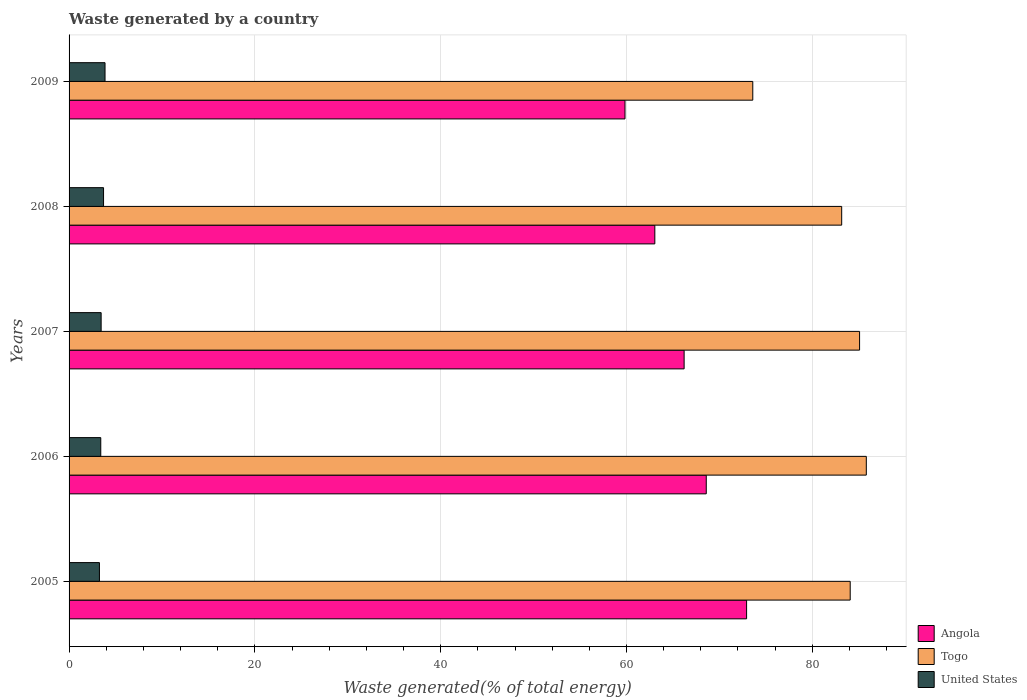How many groups of bars are there?
Make the answer very short. 5. How many bars are there on the 1st tick from the top?
Your answer should be very brief. 3. How many bars are there on the 4th tick from the bottom?
Ensure brevity in your answer.  3. What is the total waste generated in Angola in 2008?
Your answer should be very brief. 63.05. Across all years, what is the maximum total waste generated in Angola?
Provide a succinct answer. 72.93. Across all years, what is the minimum total waste generated in Angola?
Your answer should be compact. 59.84. What is the total total waste generated in Angola in the graph?
Make the answer very short. 330.61. What is the difference between the total waste generated in Angola in 2005 and that in 2008?
Your answer should be compact. 9.88. What is the difference between the total waste generated in United States in 2005 and the total waste generated in Angola in 2007?
Give a very brief answer. -62.94. What is the average total waste generated in Togo per year?
Provide a succinct answer. 82.35. In the year 2005, what is the difference between the total waste generated in Angola and total waste generated in Togo?
Provide a succinct answer. -11.15. What is the ratio of the total waste generated in United States in 2005 to that in 2008?
Ensure brevity in your answer.  0.88. What is the difference between the highest and the second highest total waste generated in Angola?
Offer a terse response. 4.34. What is the difference between the highest and the lowest total waste generated in Angola?
Your answer should be compact. 13.09. In how many years, is the total waste generated in Angola greater than the average total waste generated in Angola taken over all years?
Ensure brevity in your answer.  3. What does the 2nd bar from the bottom in 2006 represents?
Offer a very short reply. Togo. Is it the case that in every year, the sum of the total waste generated in United States and total waste generated in Angola is greater than the total waste generated in Togo?
Provide a short and direct response. No. How many years are there in the graph?
Give a very brief answer. 5. What is the difference between two consecutive major ticks on the X-axis?
Keep it short and to the point. 20. Are the values on the major ticks of X-axis written in scientific E-notation?
Keep it short and to the point. No. Does the graph contain any zero values?
Give a very brief answer. No. How are the legend labels stacked?
Keep it short and to the point. Vertical. What is the title of the graph?
Provide a succinct answer. Waste generated by a country. Does "Italy" appear as one of the legend labels in the graph?
Make the answer very short. No. What is the label or title of the X-axis?
Provide a succinct answer. Waste generated(% of total energy). What is the label or title of the Y-axis?
Offer a terse response. Years. What is the Waste generated(% of total energy) in Angola in 2005?
Keep it short and to the point. 72.93. What is the Waste generated(% of total energy) of Togo in 2005?
Your answer should be compact. 84.08. What is the Waste generated(% of total energy) in United States in 2005?
Your response must be concise. 3.27. What is the Waste generated(% of total energy) of Angola in 2006?
Provide a succinct answer. 68.59. What is the Waste generated(% of total energy) in Togo in 2006?
Your answer should be very brief. 85.82. What is the Waste generated(% of total energy) of United States in 2006?
Your response must be concise. 3.41. What is the Waste generated(% of total energy) of Angola in 2007?
Make the answer very short. 66.2. What is the Waste generated(% of total energy) in Togo in 2007?
Offer a terse response. 85.09. What is the Waste generated(% of total energy) of United States in 2007?
Your answer should be very brief. 3.45. What is the Waste generated(% of total energy) in Angola in 2008?
Your answer should be very brief. 63.05. What is the Waste generated(% of total energy) in Togo in 2008?
Give a very brief answer. 83.16. What is the Waste generated(% of total energy) of United States in 2008?
Your response must be concise. 3.71. What is the Waste generated(% of total energy) in Angola in 2009?
Provide a short and direct response. 59.84. What is the Waste generated(% of total energy) in Togo in 2009?
Ensure brevity in your answer.  73.59. What is the Waste generated(% of total energy) in United States in 2009?
Ensure brevity in your answer.  3.87. Across all years, what is the maximum Waste generated(% of total energy) of Angola?
Your response must be concise. 72.93. Across all years, what is the maximum Waste generated(% of total energy) of Togo?
Give a very brief answer. 85.82. Across all years, what is the maximum Waste generated(% of total energy) in United States?
Your answer should be compact. 3.87. Across all years, what is the minimum Waste generated(% of total energy) of Angola?
Offer a terse response. 59.84. Across all years, what is the minimum Waste generated(% of total energy) in Togo?
Offer a terse response. 73.59. Across all years, what is the minimum Waste generated(% of total energy) in United States?
Offer a terse response. 3.27. What is the total Waste generated(% of total energy) of Angola in the graph?
Give a very brief answer. 330.61. What is the total Waste generated(% of total energy) of Togo in the graph?
Offer a very short reply. 411.74. What is the total Waste generated(% of total energy) in United States in the graph?
Your answer should be compact. 17.71. What is the difference between the Waste generated(% of total energy) in Angola in 2005 and that in 2006?
Offer a very short reply. 4.34. What is the difference between the Waste generated(% of total energy) of Togo in 2005 and that in 2006?
Give a very brief answer. -1.73. What is the difference between the Waste generated(% of total energy) in United States in 2005 and that in 2006?
Your answer should be compact. -0.14. What is the difference between the Waste generated(% of total energy) of Angola in 2005 and that in 2007?
Make the answer very short. 6.72. What is the difference between the Waste generated(% of total energy) in Togo in 2005 and that in 2007?
Your answer should be compact. -1.01. What is the difference between the Waste generated(% of total energy) of United States in 2005 and that in 2007?
Give a very brief answer. -0.18. What is the difference between the Waste generated(% of total energy) in Angola in 2005 and that in 2008?
Provide a short and direct response. 9.88. What is the difference between the Waste generated(% of total energy) in Togo in 2005 and that in 2008?
Keep it short and to the point. 0.92. What is the difference between the Waste generated(% of total energy) of United States in 2005 and that in 2008?
Ensure brevity in your answer.  -0.44. What is the difference between the Waste generated(% of total energy) of Angola in 2005 and that in 2009?
Offer a terse response. 13.09. What is the difference between the Waste generated(% of total energy) of Togo in 2005 and that in 2009?
Your answer should be very brief. 10.49. What is the difference between the Waste generated(% of total energy) in United States in 2005 and that in 2009?
Provide a succinct answer. -0.6. What is the difference between the Waste generated(% of total energy) of Angola in 2006 and that in 2007?
Offer a terse response. 2.38. What is the difference between the Waste generated(% of total energy) of Togo in 2006 and that in 2007?
Provide a succinct answer. 0.73. What is the difference between the Waste generated(% of total energy) of United States in 2006 and that in 2007?
Provide a succinct answer. -0.04. What is the difference between the Waste generated(% of total energy) of Angola in 2006 and that in 2008?
Your answer should be very brief. 5.54. What is the difference between the Waste generated(% of total energy) in Togo in 2006 and that in 2008?
Give a very brief answer. 2.65. What is the difference between the Waste generated(% of total energy) of United States in 2006 and that in 2008?
Provide a short and direct response. -0.3. What is the difference between the Waste generated(% of total energy) in Angola in 2006 and that in 2009?
Offer a terse response. 8.75. What is the difference between the Waste generated(% of total energy) of Togo in 2006 and that in 2009?
Your answer should be compact. 12.22. What is the difference between the Waste generated(% of total energy) of United States in 2006 and that in 2009?
Make the answer very short. -0.46. What is the difference between the Waste generated(% of total energy) of Angola in 2007 and that in 2008?
Offer a very short reply. 3.15. What is the difference between the Waste generated(% of total energy) of Togo in 2007 and that in 2008?
Keep it short and to the point. 1.93. What is the difference between the Waste generated(% of total energy) in United States in 2007 and that in 2008?
Offer a terse response. -0.26. What is the difference between the Waste generated(% of total energy) of Angola in 2007 and that in 2009?
Offer a very short reply. 6.37. What is the difference between the Waste generated(% of total energy) of Togo in 2007 and that in 2009?
Your answer should be compact. 11.5. What is the difference between the Waste generated(% of total energy) in United States in 2007 and that in 2009?
Offer a very short reply. -0.42. What is the difference between the Waste generated(% of total energy) of Angola in 2008 and that in 2009?
Give a very brief answer. 3.21. What is the difference between the Waste generated(% of total energy) in Togo in 2008 and that in 2009?
Ensure brevity in your answer.  9.57. What is the difference between the Waste generated(% of total energy) in United States in 2008 and that in 2009?
Give a very brief answer. -0.16. What is the difference between the Waste generated(% of total energy) in Angola in 2005 and the Waste generated(% of total energy) in Togo in 2006?
Provide a short and direct response. -12.89. What is the difference between the Waste generated(% of total energy) in Angola in 2005 and the Waste generated(% of total energy) in United States in 2006?
Offer a very short reply. 69.52. What is the difference between the Waste generated(% of total energy) in Togo in 2005 and the Waste generated(% of total energy) in United States in 2006?
Offer a terse response. 80.67. What is the difference between the Waste generated(% of total energy) in Angola in 2005 and the Waste generated(% of total energy) in Togo in 2007?
Your answer should be very brief. -12.16. What is the difference between the Waste generated(% of total energy) of Angola in 2005 and the Waste generated(% of total energy) of United States in 2007?
Your answer should be very brief. 69.48. What is the difference between the Waste generated(% of total energy) in Togo in 2005 and the Waste generated(% of total energy) in United States in 2007?
Give a very brief answer. 80.63. What is the difference between the Waste generated(% of total energy) of Angola in 2005 and the Waste generated(% of total energy) of Togo in 2008?
Provide a succinct answer. -10.24. What is the difference between the Waste generated(% of total energy) in Angola in 2005 and the Waste generated(% of total energy) in United States in 2008?
Give a very brief answer. 69.22. What is the difference between the Waste generated(% of total energy) in Togo in 2005 and the Waste generated(% of total energy) in United States in 2008?
Your answer should be compact. 80.37. What is the difference between the Waste generated(% of total energy) in Angola in 2005 and the Waste generated(% of total energy) in Togo in 2009?
Offer a very short reply. -0.67. What is the difference between the Waste generated(% of total energy) of Angola in 2005 and the Waste generated(% of total energy) of United States in 2009?
Your answer should be very brief. 69.06. What is the difference between the Waste generated(% of total energy) of Togo in 2005 and the Waste generated(% of total energy) of United States in 2009?
Make the answer very short. 80.21. What is the difference between the Waste generated(% of total energy) in Angola in 2006 and the Waste generated(% of total energy) in Togo in 2007?
Offer a terse response. -16.5. What is the difference between the Waste generated(% of total energy) of Angola in 2006 and the Waste generated(% of total energy) of United States in 2007?
Make the answer very short. 65.14. What is the difference between the Waste generated(% of total energy) in Togo in 2006 and the Waste generated(% of total energy) in United States in 2007?
Provide a short and direct response. 82.36. What is the difference between the Waste generated(% of total energy) of Angola in 2006 and the Waste generated(% of total energy) of Togo in 2008?
Your response must be concise. -14.58. What is the difference between the Waste generated(% of total energy) of Angola in 2006 and the Waste generated(% of total energy) of United States in 2008?
Ensure brevity in your answer.  64.88. What is the difference between the Waste generated(% of total energy) in Togo in 2006 and the Waste generated(% of total energy) in United States in 2008?
Give a very brief answer. 82.1. What is the difference between the Waste generated(% of total energy) in Angola in 2006 and the Waste generated(% of total energy) in Togo in 2009?
Make the answer very short. -5.01. What is the difference between the Waste generated(% of total energy) in Angola in 2006 and the Waste generated(% of total energy) in United States in 2009?
Offer a terse response. 64.72. What is the difference between the Waste generated(% of total energy) of Togo in 2006 and the Waste generated(% of total energy) of United States in 2009?
Offer a terse response. 81.94. What is the difference between the Waste generated(% of total energy) in Angola in 2007 and the Waste generated(% of total energy) in Togo in 2008?
Keep it short and to the point. -16.96. What is the difference between the Waste generated(% of total energy) of Angola in 2007 and the Waste generated(% of total energy) of United States in 2008?
Give a very brief answer. 62.49. What is the difference between the Waste generated(% of total energy) in Togo in 2007 and the Waste generated(% of total energy) in United States in 2008?
Your answer should be very brief. 81.38. What is the difference between the Waste generated(% of total energy) of Angola in 2007 and the Waste generated(% of total energy) of Togo in 2009?
Your answer should be compact. -7.39. What is the difference between the Waste generated(% of total energy) in Angola in 2007 and the Waste generated(% of total energy) in United States in 2009?
Provide a short and direct response. 62.33. What is the difference between the Waste generated(% of total energy) in Togo in 2007 and the Waste generated(% of total energy) in United States in 2009?
Make the answer very short. 81.22. What is the difference between the Waste generated(% of total energy) in Angola in 2008 and the Waste generated(% of total energy) in Togo in 2009?
Your response must be concise. -10.54. What is the difference between the Waste generated(% of total energy) of Angola in 2008 and the Waste generated(% of total energy) of United States in 2009?
Offer a very short reply. 59.18. What is the difference between the Waste generated(% of total energy) in Togo in 2008 and the Waste generated(% of total energy) in United States in 2009?
Provide a short and direct response. 79.29. What is the average Waste generated(% of total energy) in Angola per year?
Your answer should be very brief. 66.12. What is the average Waste generated(% of total energy) of Togo per year?
Ensure brevity in your answer.  82.35. What is the average Waste generated(% of total energy) in United States per year?
Make the answer very short. 3.54. In the year 2005, what is the difference between the Waste generated(% of total energy) in Angola and Waste generated(% of total energy) in Togo?
Your answer should be very brief. -11.15. In the year 2005, what is the difference between the Waste generated(% of total energy) of Angola and Waste generated(% of total energy) of United States?
Provide a succinct answer. 69.66. In the year 2005, what is the difference between the Waste generated(% of total energy) of Togo and Waste generated(% of total energy) of United States?
Make the answer very short. 80.81. In the year 2006, what is the difference between the Waste generated(% of total energy) of Angola and Waste generated(% of total energy) of Togo?
Offer a terse response. -17.23. In the year 2006, what is the difference between the Waste generated(% of total energy) of Angola and Waste generated(% of total energy) of United States?
Keep it short and to the point. 65.18. In the year 2006, what is the difference between the Waste generated(% of total energy) in Togo and Waste generated(% of total energy) in United States?
Give a very brief answer. 82.4. In the year 2007, what is the difference between the Waste generated(% of total energy) of Angola and Waste generated(% of total energy) of Togo?
Offer a terse response. -18.88. In the year 2007, what is the difference between the Waste generated(% of total energy) in Angola and Waste generated(% of total energy) in United States?
Provide a succinct answer. 62.75. In the year 2007, what is the difference between the Waste generated(% of total energy) of Togo and Waste generated(% of total energy) of United States?
Provide a succinct answer. 81.64. In the year 2008, what is the difference between the Waste generated(% of total energy) of Angola and Waste generated(% of total energy) of Togo?
Give a very brief answer. -20.11. In the year 2008, what is the difference between the Waste generated(% of total energy) of Angola and Waste generated(% of total energy) of United States?
Provide a short and direct response. 59.34. In the year 2008, what is the difference between the Waste generated(% of total energy) of Togo and Waste generated(% of total energy) of United States?
Give a very brief answer. 79.45. In the year 2009, what is the difference between the Waste generated(% of total energy) in Angola and Waste generated(% of total energy) in Togo?
Keep it short and to the point. -13.75. In the year 2009, what is the difference between the Waste generated(% of total energy) in Angola and Waste generated(% of total energy) in United States?
Provide a short and direct response. 55.97. In the year 2009, what is the difference between the Waste generated(% of total energy) of Togo and Waste generated(% of total energy) of United States?
Your answer should be compact. 69.72. What is the ratio of the Waste generated(% of total energy) of Angola in 2005 to that in 2006?
Your response must be concise. 1.06. What is the ratio of the Waste generated(% of total energy) in Togo in 2005 to that in 2006?
Provide a succinct answer. 0.98. What is the ratio of the Waste generated(% of total energy) in United States in 2005 to that in 2006?
Make the answer very short. 0.96. What is the ratio of the Waste generated(% of total energy) in Angola in 2005 to that in 2007?
Offer a terse response. 1.1. What is the ratio of the Waste generated(% of total energy) in United States in 2005 to that in 2007?
Your answer should be compact. 0.95. What is the ratio of the Waste generated(% of total energy) in Angola in 2005 to that in 2008?
Give a very brief answer. 1.16. What is the ratio of the Waste generated(% of total energy) of United States in 2005 to that in 2008?
Your response must be concise. 0.88. What is the ratio of the Waste generated(% of total energy) of Angola in 2005 to that in 2009?
Your answer should be very brief. 1.22. What is the ratio of the Waste generated(% of total energy) in Togo in 2005 to that in 2009?
Your response must be concise. 1.14. What is the ratio of the Waste generated(% of total energy) in United States in 2005 to that in 2009?
Keep it short and to the point. 0.84. What is the ratio of the Waste generated(% of total energy) of Angola in 2006 to that in 2007?
Keep it short and to the point. 1.04. What is the ratio of the Waste generated(% of total energy) of Togo in 2006 to that in 2007?
Give a very brief answer. 1.01. What is the ratio of the Waste generated(% of total energy) in United States in 2006 to that in 2007?
Provide a short and direct response. 0.99. What is the ratio of the Waste generated(% of total energy) in Angola in 2006 to that in 2008?
Your answer should be very brief. 1.09. What is the ratio of the Waste generated(% of total energy) in Togo in 2006 to that in 2008?
Your answer should be very brief. 1.03. What is the ratio of the Waste generated(% of total energy) of United States in 2006 to that in 2008?
Your response must be concise. 0.92. What is the ratio of the Waste generated(% of total energy) of Angola in 2006 to that in 2009?
Provide a succinct answer. 1.15. What is the ratio of the Waste generated(% of total energy) in Togo in 2006 to that in 2009?
Provide a succinct answer. 1.17. What is the ratio of the Waste generated(% of total energy) in United States in 2006 to that in 2009?
Provide a short and direct response. 0.88. What is the ratio of the Waste generated(% of total energy) of Togo in 2007 to that in 2008?
Your answer should be very brief. 1.02. What is the ratio of the Waste generated(% of total energy) in United States in 2007 to that in 2008?
Provide a succinct answer. 0.93. What is the ratio of the Waste generated(% of total energy) in Angola in 2007 to that in 2009?
Ensure brevity in your answer.  1.11. What is the ratio of the Waste generated(% of total energy) of Togo in 2007 to that in 2009?
Provide a short and direct response. 1.16. What is the ratio of the Waste generated(% of total energy) in United States in 2007 to that in 2009?
Your answer should be very brief. 0.89. What is the ratio of the Waste generated(% of total energy) of Angola in 2008 to that in 2009?
Make the answer very short. 1.05. What is the ratio of the Waste generated(% of total energy) of Togo in 2008 to that in 2009?
Offer a very short reply. 1.13. What is the ratio of the Waste generated(% of total energy) of United States in 2008 to that in 2009?
Your response must be concise. 0.96. What is the difference between the highest and the second highest Waste generated(% of total energy) of Angola?
Offer a terse response. 4.34. What is the difference between the highest and the second highest Waste generated(% of total energy) in Togo?
Provide a succinct answer. 0.73. What is the difference between the highest and the second highest Waste generated(% of total energy) of United States?
Keep it short and to the point. 0.16. What is the difference between the highest and the lowest Waste generated(% of total energy) in Angola?
Provide a short and direct response. 13.09. What is the difference between the highest and the lowest Waste generated(% of total energy) in Togo?
Give a very brief answer. 12.22. What is the difference between the highest and the lowest Waste generated(% of total energy) of United States?
Your answer should be compact. 0.6. 